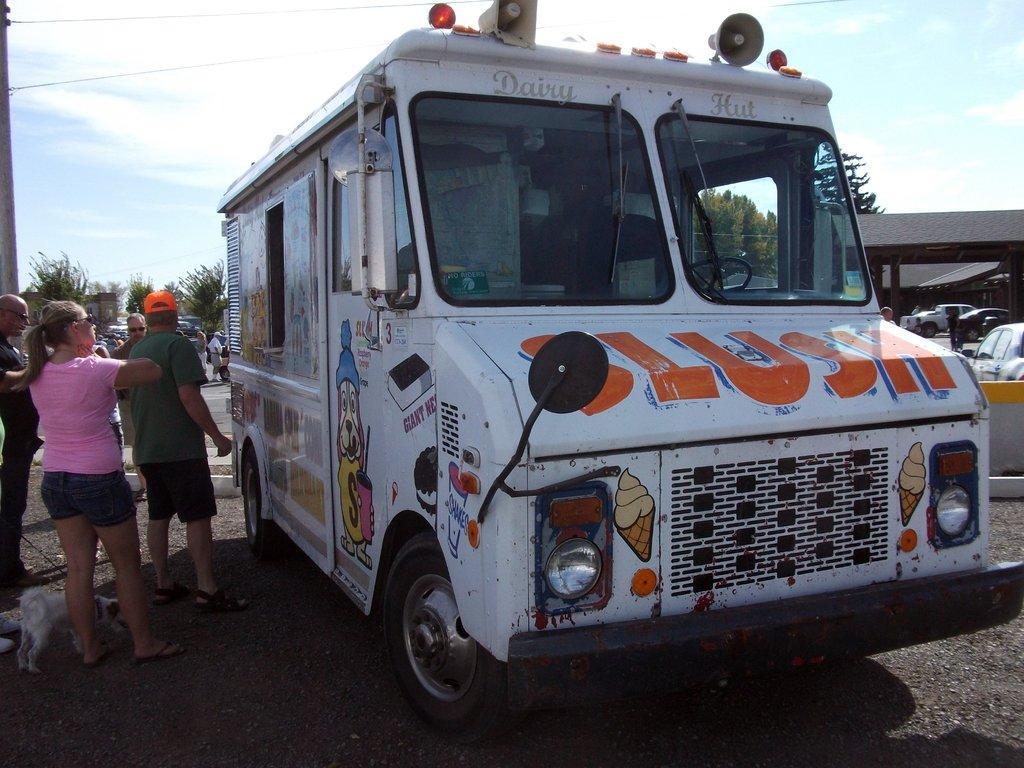Could you give a brief overview of what you see in this image? In this image I can see a truck. There are group of people, there are trees, vehicles, buildings and there is a shelter. There is a dog, a pole and in the background there is sky. 